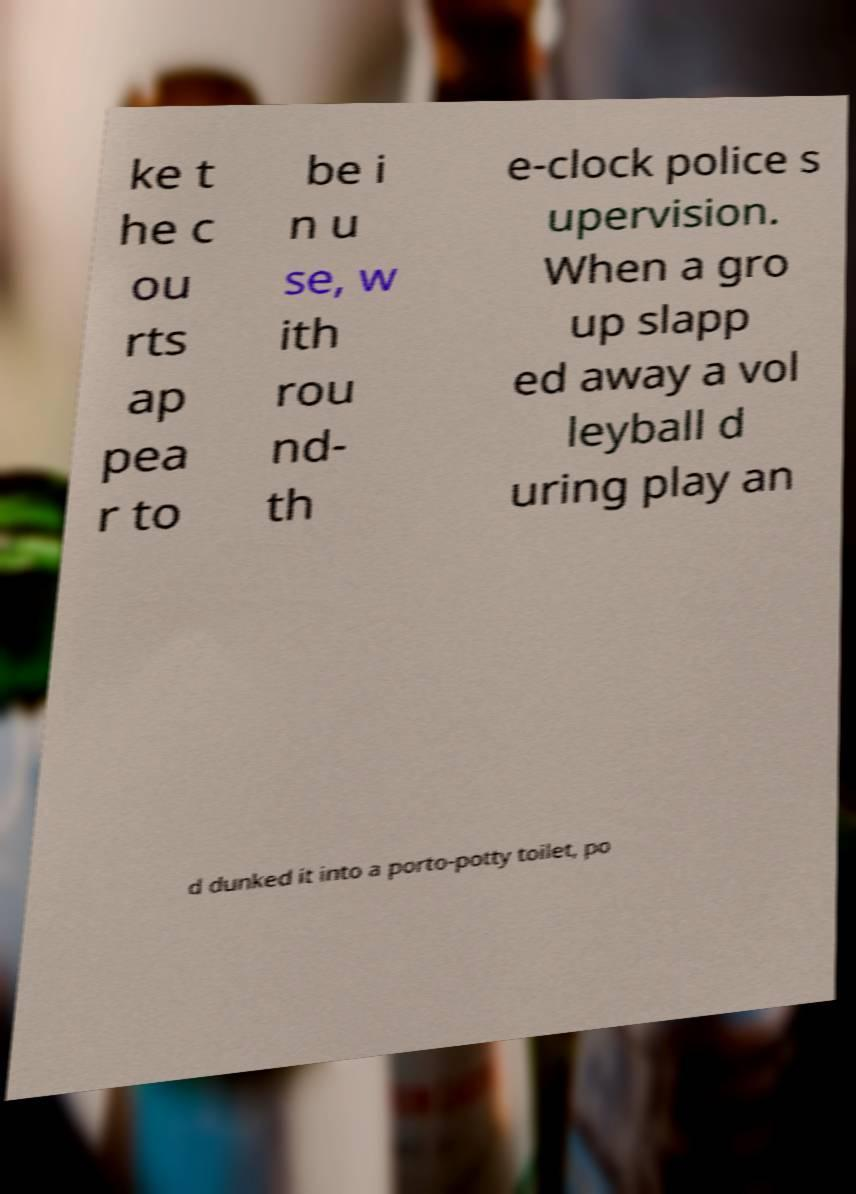Please identify and transcribe the text found in this image. ke t he c ou rts ap pea r to be i n u se, w ith rou nd- th e-clock police s upervision. When a gro up slapp ed away a vol leyball d uring play an d dunked it into a porto-potty toilet, po 